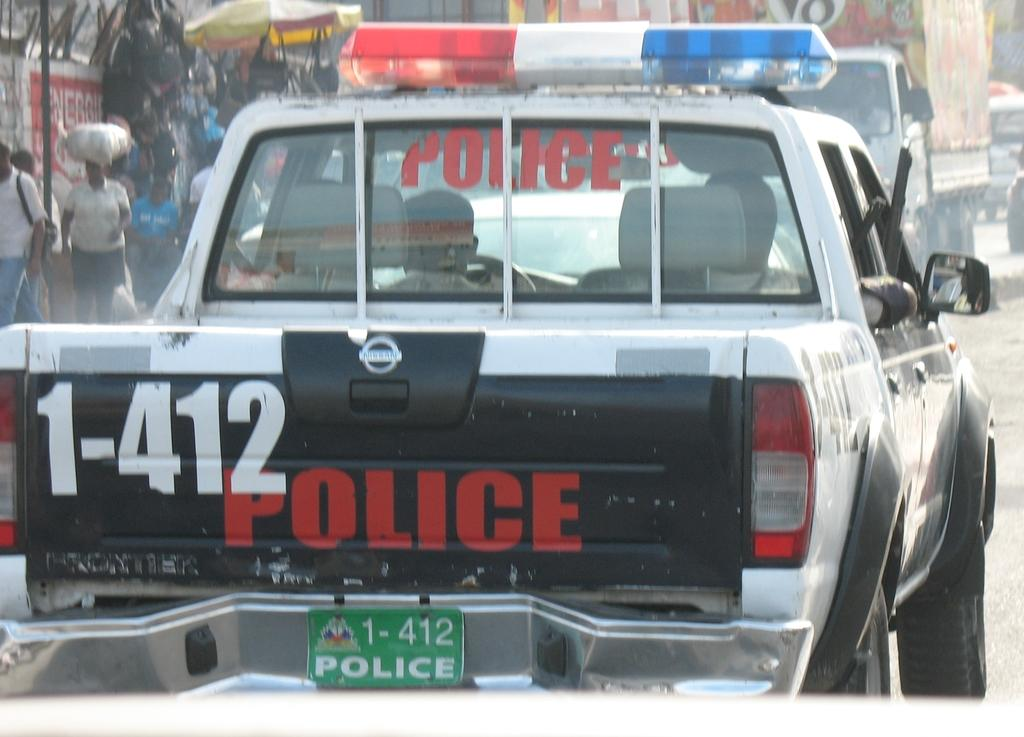What is the main subject in the center of the image? There is a car in the center of the image. Where is the car located? The car is on the road. What can be seen in the background of the image? There are persons and vehicles in the background of the image, as well as a road. How many children are involved in the trade depicted in the image? There are no children or trade-related activities present in the image. 